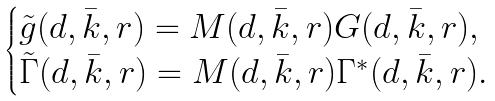Convert formula to latex. <formula><loc_0><loc_0><loc_500><loc_500>\begin{cases} \tilde { g } ( d , \bar { k } , r ) = M ( d , \bar { k } , r ) G ( d , \bar { k } , r ) , \\ \tilde { \Gamma } ( d , \bar { k } , r ) = M ( d , \bar { k } , r ) \Gamma ^ { * } ( d , \bar { k } , r ) . \end{cases}</formula> 